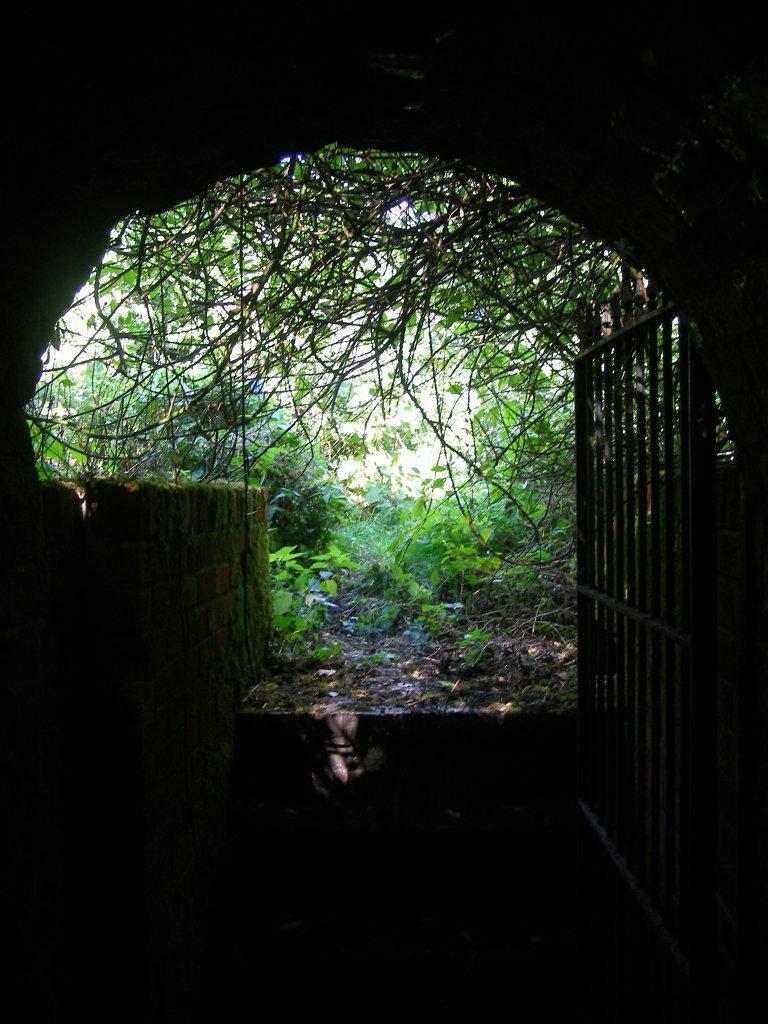Could you give a brief overview of what you see in this image? In this picture I can observe a gate on the right side. There are some plants on the ground. In the background there are trees. I can observe a tunnel. 